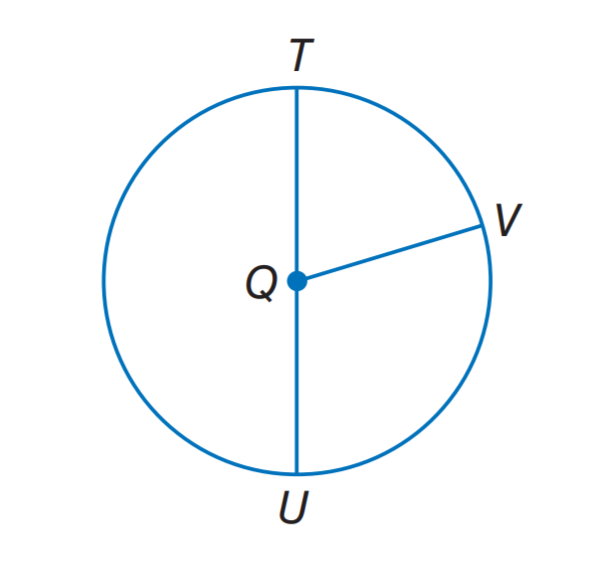Answer the mathemtical geometry problem and directly provide the correct option letter.
Question: If Q V = 8, what it the diameter of \odot Q.
Choices: A: 7 B: 8 C: 11 D: 16 D 